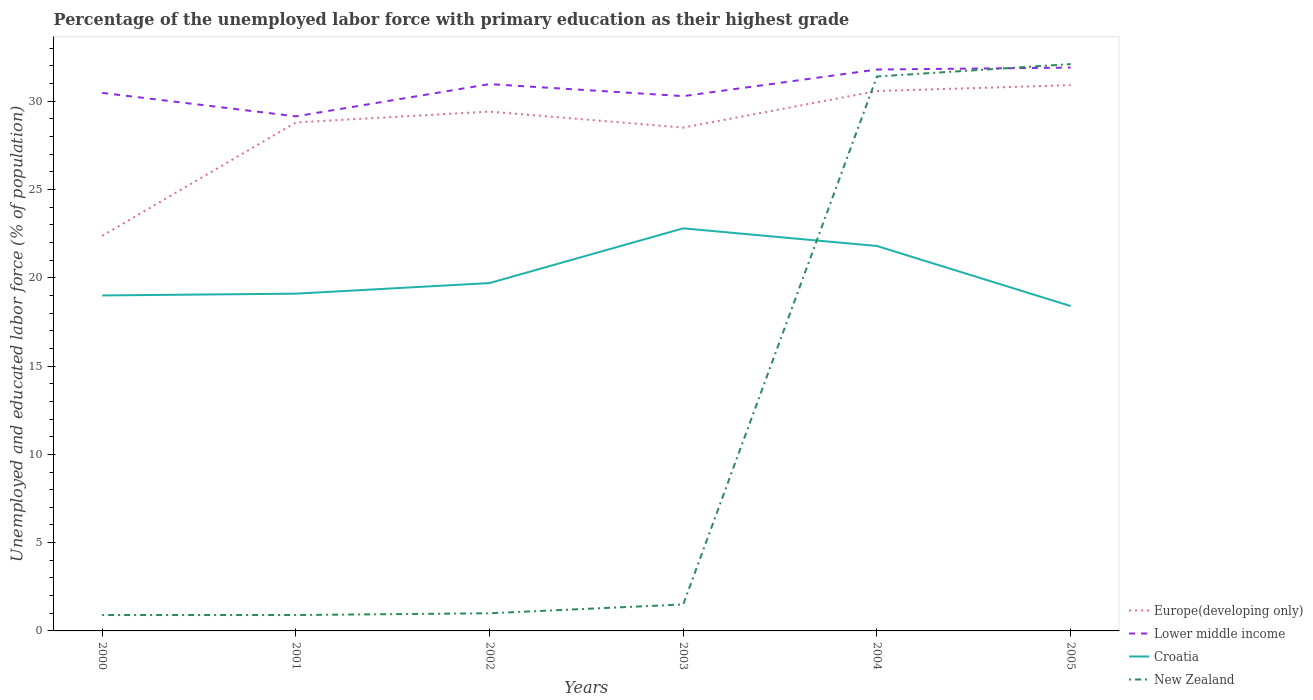How many different coloured lines are there?
Your answer should be very brief. 4. Does the line corresponding to Europe(developing only) intersect with the line corresponding to Croatia?
Your response must be concise. No. Is the number of lines equal to the number of legend labels?
Give a very brief answer. Yes. Across all years, what is the maximum percentage of the unemployed labor force with primary education in Europe(developing only)?
Offer a terse response. 22.37. In which year was the percentage of the unemployed labor force with primary education in Croatia maximum?
Your answer should be very brief. 2005. What is the total percentage of the unemployed labor force with primary education in Europe(developing only) in the graph?
Make the answer very short. -6.13. What is the difference between the highest and the second highest percentage of the unemployed labor force with primary education in Europe(developing only)?
Give a very brief answer. 8.54. Is the percentage of the unemployed labor force with primary education in Lower middle income strictly greater than the percentage of the unemployed labor force with primary education in Croatia over the years?
Keep it short and to the point. No. How many years are there in the graph?
Ensure brevity in your answer.  6. Are the values on the major ticks of Y-axis written in scientific E-notation?
Ensure brevity in your answer.  No. Where does the legend appear in the graph?
Keep it short and to the point. Bottom right. How are the legend labels stacked?
Your response must be concise. Vertical. What is the title of the graph?
Your response must be concise. Percentage of the unemployed labor force with primary education as their highest grade. What is the label or title of the Y-axis?
Give a very brief answer. Unemployed and educated labor force (% of population). What is the Unemployed and educated labor force (% of population) of Europe(developing only) in 2000?
Give a very brief answer. 22.37. What is the Unemployed and educated labor force (% of population) in Lower middle income in 2000?
Your answer should be very brief. 30.47. What is the Unemployed and educated labor force (% of population) in Croatia in 2000?
Make the answer very short. 19. What is the Unemployed and educated labor force (% of population) of New Zealand in 2000?
Offer a terse response. 0.9. What is the Unemployed and educated labor force (% of population) of Europe(developing only) in 2001?
Provide a succinct answer. 28.8. What is the Unemployed and educated labor force (% of population) in Lower middle income in 2001?
Make the answer very short. 29.14. What is the Unemployed and educated labor force (% of population) in Croatia in 2001?
Offer a terse response. 19.1. What is the Unemployed and educated labor force (% of population) of New Zealand in 2001?
Offer a very short reply. 0.9. What is the Unemployed and educated labor force (% of population) in Europe(developing only) in 2002?
Keep it short and to the point. 29.41. What is the Unemployed and educated labor force (% of population) of Lower middle income in 2002?
Keep it short and to the point. 30.97. What is the Unemployed and educated labor force (% of population) in Croatia in 2002?
Your answer should be compact. 19.7. What is the Unemployed and educated labor force (% of population) in New Zealand in 2002?
Your answer should be very brief. 1. What is the Unemployed and educated labor force (% of population) of Europe(developing only) in 2003?
Offer a terse response. 28.51. What is the Unemployed and educated labor force (% of population) in Lower middle income in 2003?
Make the answer very short. 30.29. What is the Unemployed and educated labor force (% of population) in Croatia in 2003?
Give a very brief answer. 22.8. What is the Unemployed and educated labor force (% of population) in New Zealand in 2003?
Keep it short and to the point. 1.5. What is the Unemployed and educated labor force (% of population) in Europe(developing only) in 2004?
Make the answer very short. 30.58. What is the Unemployed and educated labor force (% of population) in Lower middle income in 2004?
Provide a short and direct response. 31.79. What is the Unemployed and educated labor force (% of population) of Croatia in 2004?
Your answer should be very brief. 21.8. What is the Unemployed and educated labor force (% of population) in New Zealand in 2004?
Your response must be concise. 31.4. What is the Unemployed and educated labor force (% of population) in Europe(developing only) in 2005?
Offer a terse response. 30.91. What is the Unemployed and educated labor force (% of population) of Lower middle income in 2005?
Your response must be concise. 31.9. What is the Unemployed and educated labor force (% of population) of Croatia in 2005?
Ensure brevity in your answer.  18.4. What is the Unemployed and educated labor force (% of population) of New Zealand in 2005?
Your answer should be compact. 32.1. Across all years, what is the maximum Unemployed and educated labor force (% of population) in Europe(developing only)?
Your answer should be very brief. 30.91. Across all years, what is the maximum Unemployed and educated labor force (% of population) in Lower middle income?
Offer a terse response. 31.9. Across all years, what is the maximum Unemployed and educated labor force (% of population) of Croatia?
Make the answer very short. 22.8. Across all years, what is the maximum Unemployed and educated labor force (% of population) in New Zealand?
Give a very brief answer. 32.1. Across all years, what is the minimum Unemployed and educated labor force (% of population) in Europe(developing only)?
Your response must be concise. 22.37. Across all years, what is the minimum Unemployed and educated labor force (% of population) of Lower middle income?
Ensure brevity in your answer.  29.14. Across all years, what is the minimum Unemployed and educated labor force (% of population) in Croatia?
Offer a very short reply. 18.4. Across all years, what is the minimum Unemployed and educated labor force (% of population) in New Zealand?
Your answer should be compact. 0.9. What is the total Unemployed and educated labor force (% of population) in Europe(developing only) in the graph?
Your answer should be compact. 170.57. What is the total Unemployed and educated labor force (% of population) in Lower middle income in the graph?
Offer a terse response. 184.57. What is the total Unemployed and educated labor force (% of population) of Croatia in the graph?
Give a very brief answer. 120.8. What is the total Unemployed and educated labor force (% of population) of New Zealand in the graph?
Ensure brevity in your answer.  67.8. What is the difference between the Unemployed and educated labor force (% of population) of Europe(developing only) in 2000 and that in 2001?
Provide a succinct answer. -6.42. What is the difference between the Unemployed and educated labor force (% of population) in Lower middle income in 2000 and that in 2001?
Provide a short and direct response. 1.33. What is the difference between the Unemployed and educated labor force (% of population) of New Zealand in 2000 and that in 2001?
Ensure brevity in your answer.  0. What is the difference between the Unemployed and educated labor force (% of population) in Europe(developing only) in 2000 and that in 2002?
Provide a short and direct response. -7.04. What is the difference between the Unemployed and educated labor force (% of population) of Lower middle income in 2000 and that in 2002?
Provide a succinct answer. -0.5. What is the difference between the Unemployed and educated labor force (% of population) in Croatia in 2000 and that in 2002?
Offer a terse response. -0.7. What is the difference between the Unemployed and educated labor force (% of population) in Europe(developing only) in 2000 and that in 2003?
Make the answer very short. -6.13. What is the difference between the Unemployed and educated labor force (% of population) in Lower middle income in 2000 and that in 2003?
Offer a very short reply. 0.18. What is the difference between the Unemployed and educated labor force (% of population) in Croatia in 2000 and that in 2003?
Your response must be concise. -3.8. What is the difference between the Unemployed and educated labor force (% of population) in New Zealand in 2000 and that in 2003?
Provide a succinct answer. -0.6. What is the difference between the Unemployed and educated labor force (% of population) in Europe(developing only) in 2000 and that in 2004?
Your answer should be compact. -8.2. What is the difference between the Unemployed and educated labor force (% of population) of Lower middle income in 2000 and that in 2004?
Keep it short and to the point. -1.32. What is the difference between the Unemployed and educated labor force (% of population) of New Zealand in 2000 and that in 2004?
Make the answer very short. -30.5. What is the difference between the Unemployed and educated labor force (% of population) in Europe(developing only) in 2000 and that in 2005?
Make the answer very short. -8.54. What is the difference between the Unemployed and educated labor force (% of population) of Lower middle income in 2000 and that in 2005?
Your answer should be compact. -1.43. What is the difference between the Unemployed and educated labor force (% of population) in New Zealand in 2000 and that in 2005?
Provide a succinct answer. -31.2. What is the difference between the Unemployed and educated labor force (% of population) of Europe(developing only) in 2001 and that in 2002?
Give a very brief answer. -0.61. What is the difference between the Unemployed and educated labor force (% of population) of Lower middle income in 2001 and that in 2002?
Your answer should be compact. -1.83. What is the difference between the Unemployed and educated labor force (% of population) of Europe(developing only) in 2001 and that in 2003?
Make the answer very short. 0.29. What is the difference between the Unemployed and educated labor force (% of population) of Lower middle income in 2001 and that in 2003?
Keep it short and to the point. -1.15. What is the difference between the Unemployed and educated labor force (% of population) of Europe(developing only) in 2001 and that in 2004?
Ensure brevity in your answer.  -1.78. What is the difference between the Unemployed and educated labor force (% of population) of Lower middle income in 2001 and that in 2004?
Offer a terse response. -2.65. What is the difference between the Unemployed and educated labor force (% of population) in Croatia in 2001 and that in 2004?
Keep it short and to the point. -2.7. What is the difference between the Unemployed and educated labor force (% of population) of New Zealand in 2001 and that in 2004?
Your answer should be very brief. -30.5. What is the difference between the Unemployed and educated labor force (% of population) of Europe(developing only) in 2001 and that in 2005?
Make the answer very short. -2.11. What is the difference between the Unemployed and educated labor force (% of population) of Lower middle income in 2001 and that in 2005?
Make the answer very short. -2.76. What is the difference between the Unemployed and educated labor force (% of population) of New Zealand in 2001 and that in 2005?
Ensure brevity in your answer.  -31.2. What is the difference between the Unemployed and educated labor force (% of population) in Europe(developing only) in 2002 and that in 2003?
Offer a terse response. 0.91. What is the difference between the Unemployed and educated labor force (% of population) in Lower middle income in 2002 and that in 2003?
Ensure brevity in your answer.  0.68. What is the difference between the Unemployed and educated labor force (% of population) in Croatia in 2002 and that in 2003?
Make the answer very short. -3.1. What is the difference between the Unemployed and educated labor force (% of population) of Europe(developing only) in 2002 and that in 2004?
Provide a short and direct response. -1.16. What is the difference between the Unemployed and educated labor force (% of population) of Lower middle income in 2002 and that in 2004?
Give a very brief answer. -0.83. What is the difference between the Unemployed and educated labor force (% of population) in New Zealand in 2002 and that in 2004?
Ensure brevity in your answer.  -30.4. What is the difference between the Unemployed and educated labor force (% of population) of Europe(developing only) in 2002 and that in 2005?
Provide a short and direct response. -1.5. What is the difference between the Unemployed and educated labor force (% of population) in Lower middle income in 2002 and that in 2005?
Your response must be concise. -0.93. What is the difference between the Unemployed and educated labor force (% of population) in Croatia in 2002 and that in 2005?
Give a very brief answer. 1.3. What is the difference between the Unemployed and educated labor force (% of population) in New Zealand in 2002 and that in 2005?
Provide a succinct answer. -31.1. What is the difference between the Unemployed and educated labor force (% of population) of Europe(developing only) in 2003 and that in 2004?
Provide a succinct answer. -2.07. What is the difference between the Unemployed and educated labor force (% of population) in Lower middle income in 2003 and that in 2004?
Make the answer very short. -1.51. What is the difference between the Unemployed and educated labor force (% of population) in Croatia in 2003 and that in 2004?
Ensure brevity in your answer.  1. What is the difference between the Unemployed and educated labor force (% of population) in New Zealand in 2003 and that in 2004?
Offer a terse response. -29.9. What is the difference between the Unemployed and educated labor force (% of population) of Europe(developing only) in 2003 and that in 2005?
Your answer should be compact. -2.4. What is the difference between the Unemployed and educated labor force (% of population) in Lower middle income in 2003 and that in 2005?
Provide a short and direct response. -1.62. What is the difference between the Unemployed and educated labor force (% of population) in New Zealand in 2003 and that in 2005?
Your answer should be very brief. -30.6. What is the difference between the Unemployed and educated labor force (% of population) of Europe(developing only) in 2004 and that in 2005?
Offer a terse response. -0.33. What is the difference between the Unemployed and educated labor force (% of population) in Lower middle income in 2004 and that in 2005?
Your response must be concise. -0.11. What is the difference between the Unemployed and educated labor force (% of population) of New Zealand in 2004 and that in 2005?
Your response must be concise. -0.7. What is the difference between the Unemployed and educated labor force (% of population) in Europe(developing only) in 2000 and the Unemployed and educated labor force (% of population) in Lower middle income in 2001?
Keep it short and to the point. -6.77. What is the difference between the Unemployed and educated labor force (% of population) of Europe(developing only) in 2000 and the Unemployed and educated labor force (% of population) of Croatia in 2001?
Provide a succinct answer. 3.27. What is the difference between the Unemployed and educated labor force (% of population) of Europe(developing only) in 2000 and the Unemployed and educated labor force (% of population) of New Zealand in 2001?
Keep it short and to the point. 21.47. What is the difference between the Unemployed and educated labor force (% of population) in Lower middle income in 2000 and the Unemployed and educated labor force (% of population) in Croatia in 2001?
Your answer should be compact. 11.37. What is the difference between the Unemployed and educated labor force (% of population) of Lower middle income in 2000 and the Unemployed and educated labor force (% of population) of New Zealand in 2001?
Your answer should be very brief. 29.57. What is the difference between the Unemployed and educated labor force (% of population) of Europe(developing only) in 2000 and the Unemployed and educated labor force (% of population) of Lower middle income in 2002?
Offer a very short reply. -8.6. What is the difference between the Unemployed and educated labor force (% of population) in Europe(developing only) in 2000 and the Unemployed and educated labor force (% of population) in Croatia in 2002?
Offer a terse response. 2.67. What is the difference between the Unemployed and educated labor force (% of population) in Europe(developing only) in 2000 and the Unemployed and educated labor force (% of population) in New Zealand in 2002?
Offer a very short reply. 21.37. What is the difference between the Unemployed and educated labor force (% of population) of Lower middle income in 2000 and the Unemployed and educated labor force (% of population) of Croatia in 2002?
Your answer should be compact. 10.77. What is the difference between the Unemployed and educated labor force (% of population) of Lower middle income in 2000 and the Unemployed and educated labor force (% of population) of New Zealand in 2002?
Keep it short and to the point. 29.47. What is the difference between the Unemployed and educated labor force (% of population) in Europe(developing only) in 2000 and the Unemployed and educated labor force (% of population) in Lower middle income in 2003?
Provide a short and direct response. -7.91. What is the difference between the Unemployed and educated labor force (% of population) in Europe(developing only) in 2000 and the Unemployed and educated labor force (% of population) in Croatia in 2003?
Ensure brevity in your answer.  -0.43. What is the difference between the Unemployed and educated labor force (% of population) in Europe(developing only) in 2000 and the Unemployed and educated labor force (% of population) in New Zealand in 2003?
Keep it short and to the point. 20.87. What is the difference between the Unemployed and educated labor force (% of population) in Lower middle income in 2000 and the Unemployed and educated labor force (% of population) in Croatia in 2003?
Your response must be concise. 7.67. What is the difference between the Unemployed and educated labor force (% of population) of Lower middle income in 2000 and the Unemployed and educated labor force (% of population) of New Zealand in 2003?
Provide a short and direct response. 28.97. What is the difference between the Unemployed and educated labor force (% of population) of Croatia in 2000 and the Unemployed and educated labor force (% of population) of New Zealand in 2003?
Your response must be concise. 17.5. What is the difference between the Unemployed and educated labor force (% of population) of Europe(developing only) in 2000 and the Unemployed and educated labor force (% of population) of Lower middle income in 2004?
Provide a succinct answer. -9.42. What is the difference between the Unemployed and educated labor force (% of population) of Europe(developing only) in 2000 and the Unemployed and educated labor force (% of population) of Croatia in 2004?
Offer a terse response. 0.57. What is the difference between the Unemployed and educated labor force (% of population) of Europe(developing only) in 2000 and the Unemployed and educated labor force (% of population) of New Zealand in 2004?
Ensure brevity in your answer.  -9.03. What is the difference between the Unemployed and educated labor force (% of population) in Lower middle income in 2000 and the Unemployed and educated labor force (% of population) in Croatia in 2004?
Your answer should be compact. 8.67. What is the difference between the Unemployed and educated labor force (% of population) in Lower middle income in 2000 and the Unemployed and educated labor force (% of population) in New Zealand in 2004?
Your response must be concise. -0.93. What is the difference between the Unemployed and educated labor force (% of population) in Europe(developing only) in 2000 and the Unemployed and educated labor force (% of population) in Lower middle income in 2005?
Your answer should be very brief. -9.53. What is the difference between the Unemployed and educated labor force (% of population) in Europe(developing only) in 2000 and the Unemployed and educated labor force (% of population) in Croatia in 2005?
Your answer should be very brief. 3.97. What is the difference between the Unemployed and educated labor force (% of population) in Europe(developing only) in 2000 and the Unemployed and educated labor force (% of population) in New Zealand in 2005?
Ensure brevity in your answer.  -9.73. What is the difference between the Unemployed and educated labor force (% of population) in Lower middle income in 2000 and the Unemployed and educated labor force (% of population) in Croatia in 2005?
Your answer should be compact. 12.07. What is the difference between the Unemployed and educated labor force (% of population) of Lower middle income in 2000 and the Unemployed and educated labor force (% of population) of New Zealand in 2005?
Ensure brevity in your answer.  -1.63. What is the difference between the Unemployed and educated labor force (% of population) of Europe(developing only) in 2001 and the Unemployed and educated labor force (% of population) of Lower middle income in 2002?
Your answer should be very brief. -2.17. What is the difference between the Unemployed and educated labor force (% of population) of Europe(developing only) in 2001 and the Unemployed and educated labor force (% of population) of Croatia in 2002?
Your answer should be compact. 9.1. What is the difference between the Unemployed and educated labor force (% of population) in Europe(developing only) in 2001 and the Unemployed and educated labor force (% of population) in New Zealand in 2002?
Your answer should be compact. 27.8. What is the difference between the Unemployed and educated labor force (% of population) of Lower middle income in 2001 and the Unemployed and educated labor force (% of population) of Croatia in 2002?
Your answer should be compact. 9.44. What is the difference between the Unemployed and educated labor force (% of population) of Lower middle income in 2001 and the Unemployed and educated labor force (% of population) of New Zealand in 2002?
Keep it short and to the point. 28.14. What is the difference between the Unemployed and educated labor force (% of population) in Croatia in 2001 and the Unemployed and educated labor force (% of population) in New Zealand in 2002?
Your answer should be very brief. 18.1. What is the difference between the Unemployed and educated labor force (% of population) of Europe(developing only) in 2001 and the Unemployed and educated labor force (% of population) of Lower middle income in 2003?
Your answer should be very brief. -1.49. What is the difference between the Unemployed and educated labor force (% of population) in Europe(developing only) in 2001 and the Unemployed and educated labor force (% of population) in Croatia in 2003?
Ensure brevity in your answer.  6. What is the difference between the Unemployed and educated labor force (% of population) in Europe(developing only) in 2001 and the Unemployed and educated labor force (% of population) in New Zealand in 2003?
Provide a succinct answer. 27.3. What is the difference between the Unemployed and educated labor force (% of population) in Lower middle income in 2001 and the Unemployed and educated labor force (% of population) in Croatia in 2003?
Offer a very short reply. 6.34. What is the difference between the Unemployed and educated labor force (% of population) in Lower middle income in 2001 and the Unemployed and educated labor force (% of population) in New Zealand in 2003?
Ensure brevity in your answer.  27.64. What is the difference between the Unemployed and educated labor force (% of population) in Croatia in 2001 and the Unemployed and educated labor force (% of population) in New Zealand in 2003?
Make the answer very short. 17.6. What is the difference between the Unemployed and educated labor force (% of population) of Europe(developing only) in 2001 and the Unemployed and educated labor force (% of population) of Lower middle income in 2004?
Your answer should be compact. -3. What is the difference between the Unemployed and educated labor force (% of population) in Europe(developing only) in 2001 and the Unemployed and educated labor force (% of population) in Croatia in 2004?
Offer a terse response. 7. What is the difference between the Unemployed and educated labor force (% of population) in Europe(developing only) in 2001 and the Unemployed and educated labor force (% of population) in New Zealand in 2004?
Provide a succinct answer. -2.6. What is the difference between the Unemployed and educated labor force (% of population) in Lower middle income in 2001 and the Unemployed and educated labor force (% of population) in Croatia in 2004?
Your answer should be very brief. 7.34. What is the difference between the Unemployed and educated labor force (% of population) in Lower middle income in 2001 and the Unemployed and educated labor force (% of population) in New Zealand in 2004?
Your answer should be very brief. -2.26. What is the difference between the Unemployed and educated labor force (% of population) in Croatia in 2001 and the Unemployed and educated labor force (% of population) in New Zealand in 2004?
Provide a succinct answer. -12.3. What is the difference between the Unemployed and educated labor force (% of population) in Europe(developing only) in 2001 and the Unemployed and educated labor force (% of population) in Lower middle income in 2005?
Provide a short and direct response. -3.1. What is the difference between the Unemployed and educated labor force (% of population) of Europe(developing only) in 2001 and the Unemployed and educated labor force (% of population) of Croatia in 2005?
Keep it short and to the point. 10.4. What is the difference between the Unemployed and educated labor force (% of population) of Europe(developing only) in 2001 and the Unemployed and educated labor force (% of population) of New Zealand in 2005?
Provide a succinct answer. -3.3. What is the difference between the Unemployed and educated labor force (% of population) of Lower middle income in 2001 and the Unemployed and educated labor force (% of population) of Croatia in 2005?
Keep it short and to the point. 10.74. What is the difference between the Unemployed and educated labor force (% of population) of Lower middle income in 2001 and the Unemployed and educated labor force (% of population) of New Zealand in 2005?
Offer a very short reply. -2.96. What is the difference between the Unemployed and educated labor force (% of population) of Croatia in 2001 and the Unemployed and educated labor force (% of population) of New Zealand in 2005?
Provide a short and direct response. -13. What is the difference between the Unemployed and educated labor force (% of population) in Europe(developing only) in 2002 and the Unemployed and educated labor force (% of population) in Lower middle income in 2003?
Your answer should be very brief. -0.88. What is the difference between the Unemployed and educated labor force (% of population) in Europe(developing only) in 2002 and the Unemployed and educated labor force (% of population) in Croatia in 2003?
Your response must be concise. 6.61. What is the difference between the Unemployed and educated labor force (% of population) in Europe(developing only) in 2002 and the Unemployed and educated labor force (% of population) in New Zealand in 2003?
Make the answer very short. 27.91. What is the difference between the Unemployed and educated labor force (% of population) of Lower middle income in 2002 and the Unemployed and educated labor force (% of population) of Croatia in 2003?
Give a very brief answer. 8.17. What is the difference between the Unemployed and educated labor force (% of population) of Lower middle income in 2002 and the Unemployed and educated labor force (% of population) of New Zealand in 2003?
Offer a very short reply. 29.47. What is the difference between the Unemployed and educated labor force (% of population) of Europe(developing only) in 2002 and the Unemployed and educated labor force (% of population) of Lower middle income in 2004?
Ensure brevity in your answer.  -2.38. What is the difference between the Unemployed and educated labor force (% of population) of Europe(developing only) in 2002 and the Unemployed and educated labor force (% of population) of Croatia in 2004?
Provide a succinct answer. 7.61. What is the difference between the Unemployed and educated labor force (% of population) of Europe(developing only) in 2002 and the Unemployed and educated labor force (% of population) of New Zealand in 2004?
Your answer should be compact. -1.99. What is the difference between the Unemployed and educated labor force (% of population) of Lower middle income in 2002 and the Unemployed and educated labor force (% of population) of Croatia in 2004?
Your response must be concise. 9.17. What is the difference between the Unemployed and educated labor force (% of population) in Lower middle income in 2002 and the Unemployed and educated labor force (% of population) in New Zealand in 2004?
Provide a succinct answer. -0.43. What is the difference between the Unemployed and educated labor force (% of population) in Europe(developing only) in 2002 and the Unemployed and educated labor force (% of population) in Lower middle income in 2005?
Ensure brevity in your answer.  -2.49. What is the difference between the Unemployed and educated labor force (% of population) in Europe(developing only) in 2002 and the Unemployed and educated labor force (% of population) in Croatia in 2005?
Your response must be concise. 11.01. What is the difference between the Unemployed and educated labor force (% of population) of Europe(developing only) in 2002 and the Unemployed and educated labor force (% of population) of New Zealand in 2005?
Offer a terse response. -2.69. What is the difference between the Unemployed and educated labor force (% of population) in Lower middle income in 2002 and the Unemployed and educated labor force (% of population) in Croatia in 2005?
Your answer should be compact. 12.57. What is the difference between the Unemployed and educated labor force (% of population) in Lower middle income in 2002 and the Unemployed and educated labor force (% of population) in New Zealand in 2005?
Offer a terse response. -1.13. What is the difference between the Unemployed and educated labor force (% of population) of Croatia in 2002 and the Unemployed and educated labor force (% of population) of New Zealand in 2005?
Keep it short and to the point. -12.4. What is the difference between the Unemployed and educated labor force (% of population) in Europe(developing only) in 2003 and the Unemployed and educated labor force (% of population) in Lower middle income in 2004?
Your response must be concise. -3.29. What is the difference between the Unemployed and educated labor force (% of population) of Europe(developing only) in 2003 and the Unemployed and educated labor force (% of population) of Croatia in 2004?
Keep it short and to the point. 6.71. What is the difference between the Unemployed and educated labor force (% of population) in Europe(developing only) in 2003 and the Unemployed and educated labor force (% of population) in New Zealand in 2004?
Make the answer very short. -2.89. What is the difference between the Unemployed and educated labor force (% of population) in Lower middle income in 2003 and the Unemployed and educated labor force (% of population) in Croatia in 2004?
Your answer should be compact. 8.49. What is the difference between the Unemployed and educated labor force (% of population) of Lower middle income in 2003 and the Unemployed and educated labor force (% of population) of New Zealand in 2004?
Provide a succinct answer. -1.11. What is the difference between the Unemployed and educated labor force (% of population) in Europe(developing only) in 2003 and the Unemployed and educated labor force (% of population) in Lower middle income in 2005?
Ensure brevity in your answer.  -3.4. What is the difference between the Unemployed and educated labor force (% of population) in Europe(developing only) in 2003 and the Unemployed and educated labor force (% of population) in Croatia in 2005?
Your answer should be compact. 10.11. What is the difference between the Unemployed and educated labor force (% of population) in Europe(developing only) in 2003 and the Unemployed and educated labor force (% of population) in New Zealand in 2005?
Provide a short and direct response. -3.59. What is the difference between the Unemployed and educated labor force (% of population) in Lower middle income in 2003 and the Unemployed and educated labor force (% of population) in Croatia in 2005?
Your answer should be compact. 11.89. What is the difference between the Unemployed and educated labor force (% of population) in Lower middle income in 2003 and the Unemployed and educated labor force (% of population) in New Zealand in 2005?
Offer a terse response. -1.81. What is the difference between the Unemployed and educated labor force (% of population) in Croatia in 2003 and the Unemployed and educated labor force (% of population) in New Zealand in 2005?
Your answer should be very brief. -9.3. What is the difference between the Unemployed and educated labor force (% of population) in Europe(developing only) in 2004 and the Unemployed and educated labor force (% of population) in Lower middle income in 2005?
Your response must be concise. -1.33. What is the difference between the Unemployed and educated labor force (% of population) in Europe(developing only) in 2004 and the Unemployed and educated labor force (% of population) in Croatia in 2005?
Offer a terse response. 12.18. What is the difference between the Unemployed and educated labor force (% of population) in Europe(developing only) in 2004 and the Unemployed and educated labor force (% of population) in New Zealand in 2005?
Provide a short and direct response. -1.52. What is the difference between the Unemployed and educated labor force (% of population) of Lower middle income in 2004 and the Unemployed and educated labor force (% of population) of Croatia in 2005?
Provide a succinct answer. 13.39. What is the difference between the Unemployed and educated labor force (% of population) in Lower middle income in 2004 and the Unemployed and educated labor force (% of population) in New Zealand in 2005?
Give a very brief answer. -0.31. What is the average Unemployed and educated labor force (% of population) in Europe(developing only) per year?
Make the answer very short. 28.43. What is the average Unemployed and educated labor force (% of population) in Lower middle income per year?
Ensure brevity in your answer.  30.76. What is the average Unemployed and educated labor force (% of population) in Croatia per year?
Your response must be concise. 20.13. In the year 2000, what is the difference between the Unemployed and educated labor force (% of population) in Europe(developing only) and Unemployed and educated labor force (% of population) in Lower middle income?
Ensure brevity in your answer.  -8.1. In the year 2000, what is the difference between the Unemployed and educated labor force (% of population) of Europe(developing only) and Unemployed and educated labor force (% of population) of Croatia?
Keep it short and to the point. 3.37. In the year 2000, what is the difference between the Unemployed and educated labor force (% of population) of Europe(developing only) and Unemployed and educated labor force (% of population) of New Zealand?
Offer a very short reply. 21.47. In the year 2000, what is the difference between the Unemployed and educated labor force (% of population) in Lower middle income and Unemployed and educated labor force (% of population) in Croatia?
Your answer should be compact. 11.47. In the year 2000, what is the difference between the Unemployed and educated labor force (% of population) in Lower middle income and Unemployed and educated labor force (% of population) in New Zealand?
Your answer should be very brief. 29.57. In the year 2001, what is the difference between the Unemployed and educated labor force (% of population) of Europe(developing only) and Unemployed and educated labor force (% of population) of Lower middle income?
Offer a very short reply. -0.34. In the year 2001, what is the difference between the Unemployed and educated labor force (% of population) of Europe(developing only) and Unemployed and educated labor force (% of population) of Croatia?
Offer a very short reply. 9.7. In the year 2001, what is the difference between the Unemployed and educated labor force (% of population) in Europe(developing only) and Unemployed and educated labor force (% of population) in New Zealand?
Your response must be concise. 27.9. In the year 2001, what is the difference between the Unemployed and educated labor force (% of population) of Lower middle income and Unemployed and educated labor force (% of population) of Croatia?
Offer a terse response. 10.04. In the year 2001, what is the difference between the Unemployed and educated labor force (% of population) of Lower middle income and Unemployed and educated labor force (% of population) of New Zealand?
Your answer should be compact. 28.24. In the year 2001, what is the difference between the Unemployed and educated labor force (% of population) in Croatia and Unemployed and educated labor force (% of population) in New Zealand?
Offer a very short reply. 18.2. In the year 2002, what is the difference between the Unemployed and educated labor force (% of population) in Europe(developing only) and Unemployed and educated labor force (% of population) in Lower middle income?
Offer a very short reply. -1.56. In the year 2002, what is the difference between the Unemployed and educated labor force (% of population) in Europe(developing only) and Unemployed and educated labor force (% of population) in Croatia?
Provide a short and direct response. 9.71. In the year 2002, what is the difference between the Unemployed and educated labor force (% of population) in Europe(developing only) and Unemployed and educated labor force (% of population) in New Zealand?
Your answer should be very brief. 28.41. In the year 2002, what is the difference between the Unemployed and educated labor force (% of population) of Lower middle income and Unemployed and educated labor force (% of population) of Croatia?
Your response must be concise. 11.27. In the year 2002, what is the difference between the Unemployed and educated labor force (% of population) in Lower middle income and Unemployed and educated labor force (% of population) in New Zealand?
Provide a short and direct response. 29.97. In the year 2003, what is the difference between the Unemployed and educated labor force (% of population) of Europe(developing only) and Unemployed and educated labor force (% of population) of Lower middle income?
Ensure brevity in your answer.  -1.78. In the year 2003, what is the difference between the Unemployed and educated labor force (% of population) of Europe(developing only) and Unemployed and educated labor force (% of population) of Croatia?
Your answer should be compact. 5.71. In the year 2003, what is the difference between the Unemployed and educated labor force (% of population) in Europe(developing only) and Unemployed and educated labor force (% of population) in New Zealand?
Offer a terse response. 27.01. In the year 2003, what is the difference between the Unemployed and educated labor force (% of population) of Lower middle income and Unemployed and educated labor force (% of population) of Croatia?
Give a very brief answer. 7.49. In the year 2003, what is the difference between the Unemployed and educated labor force (% of population) in Lower middle income and Unemployed and educated labor force (% of population) in New Zealand?
Make the answer very short. 28.79. In the year 2003, what is the difference between the Unemployed and educated labor force (% of population) in Croatia and Unemployed and educated labor force (% of population) in New Zealand?
Make the answer very short. 21.3. In the year 2004, what is the difference between the Unemployed and educated labor force (% of population) of Europe(developing only) and Unemployed and educated labor force (% of population) of Lower middle income?
Make the answer very short. -1.22. In the year 2004, what is the difference between the Unemployed and educated labor force (% of population) of Europe(developing only) and Unemployed and educated labor force (% of population) of Croatia?
Make the answer very short. 8.78. In the year 2004, what is the difference between the Unemployed and educated labor force (% of population) of Europe(developing only) and Unemployed and educated labor force (% of population) of New Zealand?
Keep it short and to the point. -0.82. In the year 2004, what is the difference between the Unemployed and educated labor force (% of population) in Lower middle income and Unemployed and educated labor force (% of population) in Croatia?
Provide a succinct answer. 9.99. In the year 2004, what is the difference between the Unemployed and educated labor force (% of population) of Lower middle income and Unemployed and educated labor force (% of population) of New Zealand?
Your answer should be very brief. 0.39. In the year 2004, what is the difference between the Unemployed and educated labor force (% of population) in Croatia and Unemployed and educated labor force (% of population) in New Zealand?
Provide a succinct answer. -9.6. In the year 2005, what is the difference between the Unemployed and educated labor force (% of population) of Europe(developing only) and Unemployed and educated labor force (% of population) of Lower middle income?
Your response must be concise. -0.99. In the year 2005, what is the difference between the Unemployed and educated labor force (% of population) of Europe(developing only) and Unemployed and educated labor force (% of population) of Croatia?
Give a very brief answer. 12.51. In the year 2005, what is the difference between the Unemployed and educated labor force (% of population) in Europe(developing only) and Unemployed and educated labor force (% of population) in New Zealand?
Make the answer very short. -1.19. In the year 2005, what is the difference between the Unemployed and educated labor force (% of population) in Lower middle income and Unemployed and educated labor force (% of population) in Croatia?
Give a very brief answer. 13.5. In the year 2005, what is the difference between the Unemployed and educated labor force (% of population) in Lower middle income and Unemployed and educated labor force (% of population) in New Zealand?
Ensure brevity in your answer.  -0.2. In the year 2005, what is the difference between the Unemployed and educated labor force (% of population) of Croatia and Unemployed and educated labor force (% of population) of New Zealand?
Give a very brief answer. -13.7. What is the ratio of the Unemployed and educated labor force (% of population) of Europe(developing only) in 2000 to that in 2001?
Provide a short and direct response. 0.78. What is the ratio of the Unemployed and educated labor force (% of population) of Lower middle income in 2000 to that in 2001?
Offer a terse response. 1.05. What is the ratio of the Unemployed and educated labor force (% of population) of New Zealand in 2000 to that in 2001?
Make the answer very short. 1. What is the ratio of the Unemployed and educated labor force (% of population) of Europe(developing only) in 2000 to that in 2002?
Provide a succinct answer. 0.76. What is the ratio of the Unemployed and educated labor force (% of population) in Lower middle income in 2000 to that in 2002?
Your answer should be compact. 0.98. What is the ratio of the Unemployed and educated labor force (% of population) of Croatia in 2000 to that in 2002?
Provide a short and direct response. 0.96. What is the ratio of the Unemployed and educated labor force (% of population) of New Zealand in 2000 to that in 2002?
Give a very brief answer. 0.9. What is the ratio of the Unemployed and educated labor force (% of population) in Europe(developing only) in 2000 to that in 2003?
Give a very brief answer. 0.78. What is the ratio of the Unemployed and educated labor force (% of population) of Croatia in 2000 to that in 2003?
Offer a very short reply. 0.83. What is the ratio of the Unemployed and educated labor force (% of population) of New Zealand in 2000 to that in 2003?
Provide a succinct answer. 0.6. What is the ratio of the Unemployed and educated labor force (% of population) in Europe(developing only) in 2000 to that in 2004?
Keep it short and to the point. 0.73. What is the ratio of the Unemployed and educated labor force (% of population) of Lower middle income in 2000 to that in 2004?
Offer a very short reply. 0.96. What is the ratio of the Unemployed and educated labor force (% of population) of Croatia in 2000 to that in 2004?
Provide a succinct answer. 0.87. What is the ratio of the Unemployed and educated labor force (% of population) in New Zealand in 2000 to that in 2004?
Keep it short and to the point. 0.03. What is the ratio of the Unemployed and educated labor force (% of population) in Europe(developing only) in 2000 to that in 2005?
Offer a very short reply. 0.72. What is the ratio of the Unemployed and educated labor force (% of population) in Lower middle income in 2000 to that in 2005?
Keep it short and to the point. 0.96. What is the ratio of the Unemployed and educated labor force (% of population) in Croatia in 2000 to that in 2005?
Offer a terse response. 1.03. What is the ratio of the Unemployed and educated labor force (% of population) in New Zealand in 2000 to that in 2005?
Your response must be concise. 0.03. What is the ratio of the Unemployed and educated labor force (% of population) of Europe(developing only) in 2001 to that in 2002?
Keep it short and to the point. 0.98. What is the ratio of the Unemployed and educated labor force (% of population) in Lower middle income in 2001 to that in 2002?
Offer a terse response. 0.94. What is the ratio of the Unemployed and educated labor force (% of population) in Croatia in 2001 to that in 2002?
Make the answer very short. 0.97. What is the ratio of the Unemployed and educated labor force (% of population) of New Zealand in 2001 to that in 2002?
Give a very brief answer. 0.9. What is the ratio of the Unemployed and educated labor force (% of population) of Europe(developing only) in 2001 to that in 2003?
Give a very brief answer. 1.01. What is the ratio of the Unemployed and educated labor force (% of population) of Lower middle income in 2001 to that in 2003?
Keep it short and to the point. 0.96. What is the ratio of the Unemployed and educated labor force (% of population) of Croatia in 2001 to that in 2003?
Provide a short and direct response. 0.84. What is the ratio of the Unemployed and educated labor force (% of population) of Europe(developing only) in 2001 to that in 2004?
Give a very brief answer. 0.94. What is the ratio of the Unemployed and educated labor force (% of population) of Lower middle income in 2001 to that in 2004?
Your response must be concise. 0.92. What is the ratio of the Unemployed and educated labor force (% of population) in Croatia in 2001 to that in 2004?
Keep it short and to the point. 0.88. What is the ratio of the Unemployed and educated labor force (% of population) of New Zealand in 2001 to that in 2004?
Provide a succinct answer. 0.03. What is the ratio of the Unemployed and educated labor force (% of population) in Europe(developing only) in 2001 to that in 2005?
Your answer should be very brief. 0.93. What is the ratio of the Unemployed and educated labor force (% of population) in Lower middle income in 2001 to that in 2005?
Provide a short and direct response. 0.91. What is the ratio of the Unemployed and educated labor force (% of population) in Croatia in 2001 to that in 2005?
Offer a terse response. 1.04. What is the ratio of the Unemployed and educated labor force (% of population) in New Zealand in 2001 to that in 2005?
Your answer should be very brief. 0.03. What is the ratio of the Unemployed and educated labor force (% of population) of Europe(developing only) in 2002 to that in 2003?
Your answer should be compact. 1.03. What is the ratio of the Unemployed and educated labor force (% of population) in Lower middle income in 2002 to that in 2003?
Your response must be concise. 1.02. What is the ratio of the Unemployed and educated labor force (% of population) of Croatia in 2002 to that in 2003?
Keep it short and to the point. 0.86. What is the ratio of the Unemployed and educated labor force (% of population) of Europe(developing only) in 2002 to that in 2004?
Your response must be concise. 0.96. What is the ratio of the Unemployed and educated labor force (% of population) in Lower middle income in 2002 to that in 2004?
Offer a terse response. 0.97. What is the ratio of the Unemployed and educated labor force (% of population) of Croatia in 2002 to that in 2004?
Offer a terse response. 0.9. What is the ratio of the Unemployed and educated labor force (% of population) of New Zealand in 2002 to that in 2004?
Provide a succinct answer. 0.03. What is the ratio of the Unemployed and educated labor force (% of population) in Europe(developing only) in 2002 to that in 2005?
Your answer should be compact. 0.95. What is the ratio of the Unemployed and educated labor force (% of population) of Lower middle income in 2002 to that in 2005?
Make the answer very short. 0.97. What is the ratio of the Unemployed and educated labor force (% of population) in Croatia in 2002 to that in 2005?
Offer a terse response. 1.07. What is the ratio of the Unemployed and educated labor force (% of population) in New Zealand in 2002 to that in 2005?
Ensure brevity in your answer.  0.03. What is the ratio of the Unemployed and educated labor force (% of population) of Europe(developing only) in 2003 to that in 2004?
Keep it short and to the point. 0.93. What is the ratio of the Unemployed and educated labor force (% of population) of Lower middle income in 2003 to that in 2004?
Your answer should be compact. 0.95. What is the ratio of the Unemployed and educated labor force (% of population) in Croatia in 2003 to that in 2004?
Make the answer very short. 1.05. What is the ratio of the Unemployed and educated labor force (% of population) of New Zealand in 2003 to that in 2004?
Your response must be concise. 0.05. What is the ratio of the Unemployed and educated labor force (% of population) in Europe(developing only) in 2003 to that in 2005?
Your answer should be compact. 0.92. What is the ratio of the Unemployed and educated labor force (% of population) in Lower middle income in 2003 to that in 2005?
Provide a succinct answer. 0.95. What is the ratio of the Unemployed and educated labor force (% of population) in Croatia in 2003 to that in 2005?
Make the answer very short. 1.24. What is the ratio of the Unemployed and educated labor force (% of population) of New Zealand in 2003 to that in 2005?
Give a very brief answer. 0.05. What is the ratio of the Unemployed and educated labor force (% of population) in Croatia in 2004 to that in 2005?
Make the answer very short. 1.18. What is the ratio of the Unemployed and educated labor force (% of population) of New Zealand in 2004 to that in 2005?
Provide a short and direct response. 0.98. What is the difference between the highest and the second highest Unemployed and educated labor force (% of population) in Europe(developing only)?
Give a very brief answer. 0.33. What is the difference between the highest and the second highest Unemployed and educated labor force (% of population) of Lower middle income?
Keep it short and to the point. 0.11. What is the difference between the highest and the second highest Unemployed and educated labor force (% of population) in New Zealand?
Provide a succinct answer. 0.7. What is the difference between the highest and the lowest Unemployed and educated labor force (% of population) in Europe(developing only)?
Provide a succinct answer. 8.54. What is the difference between the highest and the lowest Unemployed and educated labor force (% of population) of Lower middle income?
Ensure brevity in your answer.  2.76. What is the difference between the highest and the lowest Unemployed and educated labor force (% of population) in New Zealand?
Your response must be concise. 31.2. 